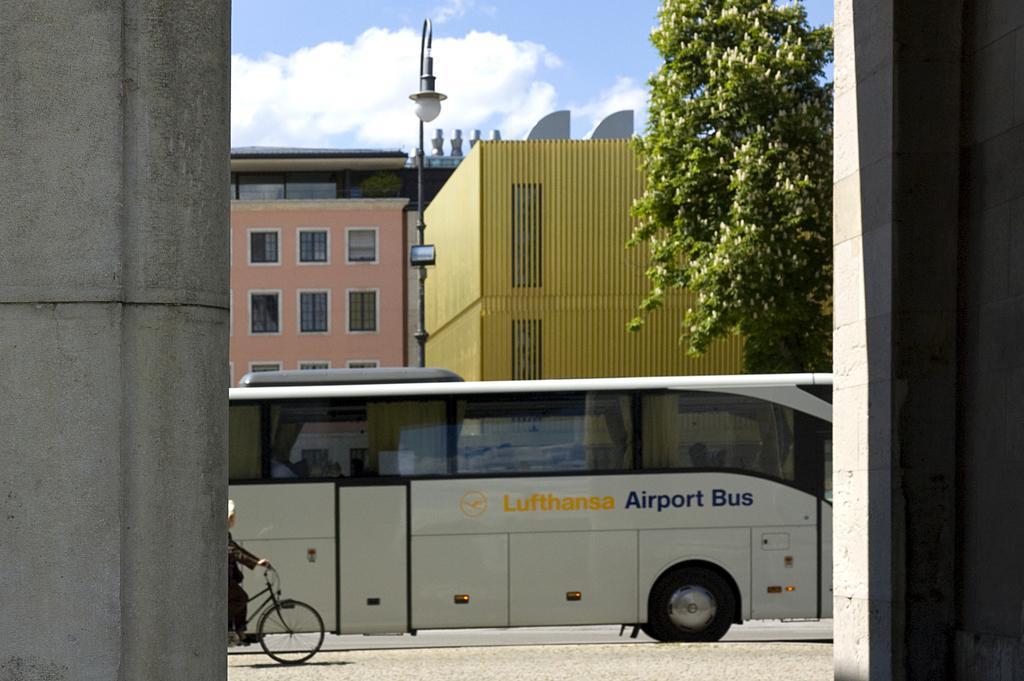Could you give a brief overview of what you see in this image? In this image there is a bus on a road and a person cycling, in the background there are buildings, trees and the sky, on the right side and left side there are pillars. 